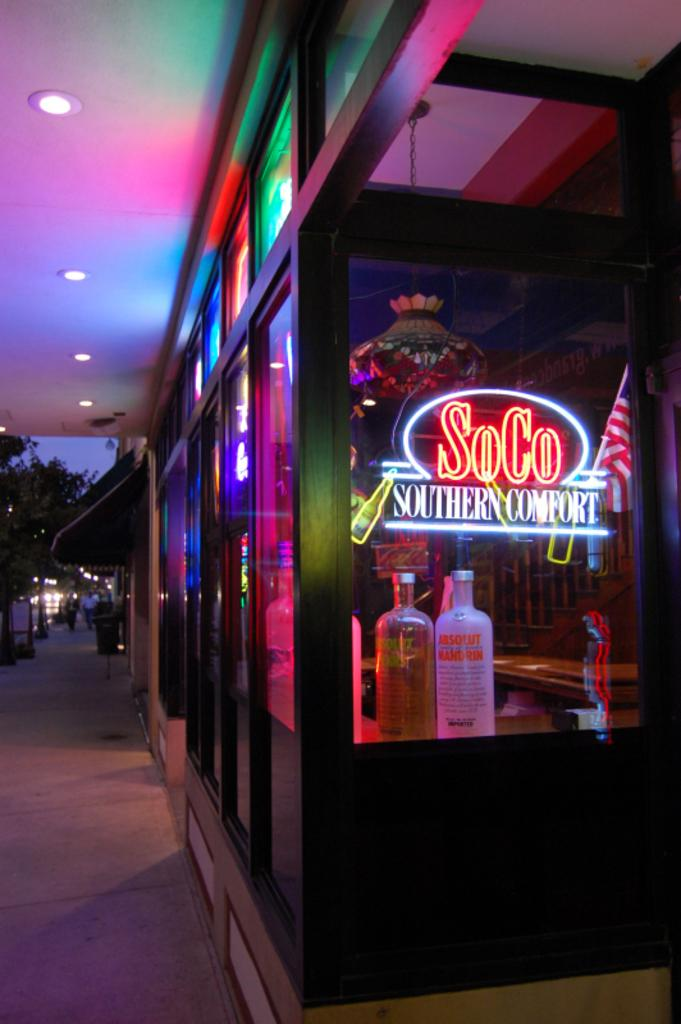What type of establishment is located in the right corner of the image? There is a store in the right corner of the image. What is the name of the store? The store has "Southern Comfort" written on it. What can be seen beside the store in the image? There is a street view beside the store. What is happening in the background of the image? A group of people is walking in the background of the image. Where can the cactus be found in the image? There is no cactus present in the image. What type of dolls are being sold in the store? The image does not provide information about the store's inventory, so it cannot be determined if dolls are being sold. 